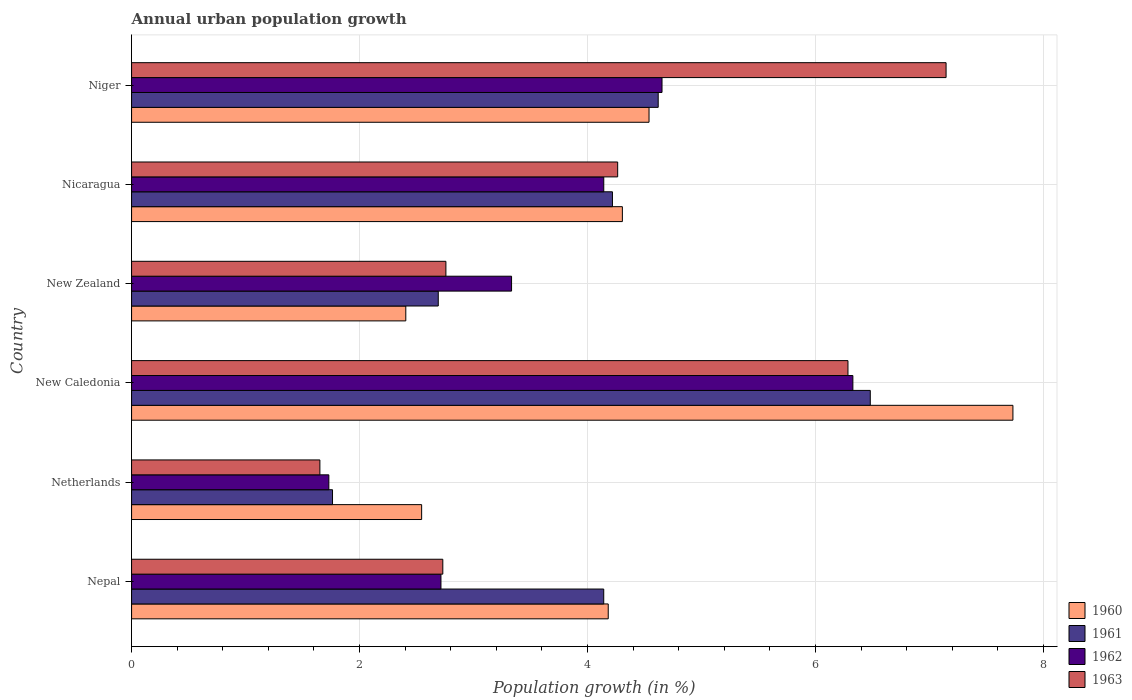Are the number of bars per tick equal to the number of legend labels?
Provide a succinct answer. Yes. Are the number of bars on each tick of the Y-axis equal?
Your answer should be compact. Yes. How many bars are there on the 3rd tick from the top?
Your answer should be compact. 4. What is the label of the 2nd group of bars from the top?
Your response must be concise. Nicaragua. What is the percentage of urban population growth in 1962 in Netherlands?
Ensure brevity in your answer.  1.73. Across all countries, what is the maximum percentage of urban population growth in 1961?
Your response must be concise. 6.48. Across all countries, what is the minimum percentage of urban population growth in 1961?
Offer a very short reply. 1.76. In which country was the percentage of urban population growth in 1963 maximum?
Ensure brevity in your answer.  Niger. In which country was the percentage of urban population growth in 1960 minimum?
Make the answer very short. New Zealand. What is the total percentage of urban population growth in 1963 in the graph?
Give a very brief answer. 24.83. What is the difference between the percentage of urban population growth in 1961 in Netherlands and that in Niger?
Offer a very short reply. -2.86. What is the difference between the percentage of urban population growth in 1962 in Nepal and the percentage of urban population growth in 1961 in New Caledonia?
Offer a very short reply. -3.77. What is the average percentage of urban population growth in 1961 per country?
Offer a terse response. 3.99. What is the difference between the percentage of urban population growth in 1962 and percentage of urban population growth in 1961 in Netherlands?
Provide a succinct answer. -0.03. In how many countries, is the percentage of urban population growth in 1962 greater than 3.6 %?
Provide a short and direct response. 3. What is the ratio of the percentage of urban population growth in 1961 in New Zealand to that in Nicaragua?
Offer a terse response. 0.64. Is the percentage of urban population growth in 1960 in New Caledonia less than that in Niger?
Keep it short and to the point. No. What is the difference between the highest and the second highest percentage of urban population growth in 1961?
Your answer should be compact. 1.86. What is the difference between the highest and the lowest percentage of urban population growth in 1963?
Keep it short and to the point. 5.49. Is it the case that in every country, the sum of the percentage of urban population growth in 1962 and percentage of urban population growth in 1960 is greater than the sum of percentage of urban population growth in 1961 and percentage of urban population growth in 1963?
Give a very brief answer. No. What does the 2nd bar from the top in Nicaragua represents?
Your answer should be very brief. 1962. How many bars are there?
Your response must be concise. 24. Are all the bars in the graph horizontal?
Give a very brief answer. Yes. How many countries are there in the graph?
Your answer should be compact. 6. Does the graph contain grids?
Ensure brevity in your answer.  Yes. How many legend labels are there?
Your answer should be very brief. 4. What is the title of the graph?
Your answer should be compact. Annual urban population growth. Does "1991" appear as one of the legend labels in the graph?
Ensure brevity in your answer.  No. What is the label or title of the X-axis?
Your response must be concise. Population growth (in %). What is the label or title of the Y-axis?
Provide a succinct answer. Country. What is the Population growth (in %) of 1960 in Nepal?
Offer a terse response. 4.18. What is the Population growth (in %) of 1961 in Nepal?
Your response must be concise. 4.14. What is the Population growth (in %) of 1962 in Nepal?
Your response must be concise. 2.71. What is the Population growth (in %) of 1963 in Nepal?
Your answer should be compact. 2.73. What is the Population growth (in %) in 1960 in Netherlands?
Offer a very short reply. 2.54. What is the Population growth (in %) of 1961 in Netherlands?
Keep it short and to the point. 1.76. What is the Population growth (in %) of 1962 in Netherlands?
Provide a succinct answer. 1.73. What is the Population growth (in %) in 1963 in Netherlands?
Your answer should be very brief. 1.65. What is the Population growth (in %) in 1960 in New Caledonia?
Make the answer very short. 7.73. What is the Population growth (in %) of 1961 in New Caledonia?
Ensure brevity in your answer.  6.48. What is the Population growth (in %) in 1962 in New Caledonia?
Provide a succinct answer. 6.33. What is the Population growth (in %) of 1963 in New Caledonia?
Keep it short and to the point. 6.28. What is the Population growth (in %) of 1960 in New Zealand?
Make the answer very short. 2.41. What is the Population growth (in %) of 1961 in New Zealand?
Make the answer very short. 2.69. What is the Population growth (in %) in 1962 in New Zealand?
Provide a short and direct response. 3.33. What is the Population growth (in %) of 1963 in New Zealand?
Your response must be concise. 2.76. What is the Population growth (in %) in 1960 in Nicaragua?
Keep it short and to the point. 4.31. What is the Population growth (in %) of 1961 in Nicaragua?
Your answer should be very brief. 4.22. What is the Population growth (in %) of 1962 in Nicaragua?
Provide a short and direct response. 4.14. What is the Population growth (in %) in 1963 in Nicaragua?
Your response must be concise. 4.26. What is the Population growth (in %) in 1960 in Niger?
Provide a succinct answer. 4.54. What is the Population growth (in %) in 1961 in Niger?
Offer a very short reply. 4.62. What is the Population growth (in %) in 1962 in Niger?
Make the answer very short. 4.65. What is the Population growth (in %) in 1963 in Niger?
Your response must be concise. 7.15. Across all countries, what is the maximum Population growth (in %) of 1960?
Offer a terse response. 7.73. Across all countries, what is the maximum Population growth (in %) in 1961?
Keep it short and to the point. 6.48. Across all countries, what is the maximum Population growth (in %) of 1962?
Ensure brevity in your answer.  6.33. Across all countries, what is the maximum Population growth (in %) of 1963?
Ensure brevity in your answer.  7.15. Across all countries, what is the minimum Population growth (in %) in 1960?
Offer a very short reply. 2.41. Across all countries, what is the minimum Population growth (in %) of 1961?
Your answer should be very brief. 1.76. Across all countries, what is the minimum Population growth (in %) in 1962?
Provide a succinct answer. 1.73. Across all countries, what is the minimum Population growth (in %) in 1963?
Keep it short and to the point. 1.65. What is the total Population growth (in %) of 1960 in the graph?
Offer a terse response. 25.71. What is the total Population growth (in %) of 1961 in the graph?
Provide a short and direct response. 23.91. What is the total Population growth (in %) of 1962 in the graph?
Your response must be concise. 22.9. What is the total Population growth (in %) of 1963 in the graph?
Your answer should be compact. 24.83. What is the difference between the Population growth (in %) of 1960 in Nepal and that in Netherlands?
Offer a terse response. 1.64. What is the difference between the Population growth (in %) of 1961 in Nepal and that in Netherlands?
Provide a succinct answer. 2.38. What is the difference between the Population growth (in %) of 1962 in Nepal and that in Netherlands?
Give a very brief answer. 0.98. What is the difference between the Population growth (in %) of 1963 in Nepal and that in Netherlands?
Make the answer very short. 1.08. What is the difference between the Population growth (in %) in 1960 in Nepal and that in New Caledonia?
Ensure brevity in your answer.  -3.55. What is the difference between the Population growth (in %) of 1961 in Nepal and that in New Caledonia?
Your response must be concise. -2.34. What is the difference between the Population growth (in %) of 1962 in Nepal and that in New Caledonia?
Give a very brief answer. -3.61. What is the difference between the Population growth (in %) in 1963 in Nepal and that in New Caledonia?
Provide a short and direct response. -3.55. What is the difference between the Population growth (in %) in 1960 in Nepal and that in New Zealand?
Keep it short and to the point. 1.78. What is the difference between the Population growth (in %) of 1961 in Nepal and that in New Zealand?
Offer a terse response. 1.45. What is the difference between the Population growth (in %) of 1962 in Nepal and that in New Zealand?
Make the answer very short. -0.62. What is the difference between the Population growth (in %) of 1963 in Nepal and that in New Zealand?
Your response must be concise. -0.03. What is the difference between the Population growth (in %) of 1960 in Nepal and that in Nicaragua?
Your response must be concise. -0.12. What is the difference between the Population growth (in %) in 1961 in Nepal and that in Nicaragua?
Offer a very short reply. -0.08. What is the difference between the Population growth (in %) of 1962 in Nepal and that in Nicaragua?
Your answer should be very brief. -1.43. What is the difference between the Population growth (in %) in 1963 in Nepal and that in Nicaragua?
Provide a short and direct response. -1.53. What is the difference between the Population growth (in %) in 1960 in Nepal and that in Niger?
Your response must be concise. -0.36. What is the difference between the Population growth (in %) of 1961 in Nepal and that in Niger?
Offer a terse response. -0.48. What is the difference between the Population growth (in %) in 1962 in Nepal and that in Niger?
Your answer should be very brief. -1.94. What is the difference between the Population growth (in %) of 1963 in Nepal and that in Niger?
Keep it short and to the point. -4.42. What is the difference between the Population growth (in %) in 1960 in Netherlands and that in New Caledonia?
Your answer should be compact. -5.19. What is the difference between the Population growth (in %) of 1961 in Netherlands and that in New Caledonia?
Provide a succinct answer. -4.72. What is the difference between the Population growth (in %) in 1962 in Netherlands and that in New Caledonia?
Provide a short and direct response. -4.6. What is the difference between the Population growth (in %) in 1963 in Netherlands and that in New Caledonia?
Keep it short and to the point. -4.63. What is the difference between the Population growth (in %) in 1960 in Netherlands and that in New Zealand?
Make the answer very short. 0.14. What is the difference between the Population growth (in %) of 1961 in Netherlands and that in New Zealand?
Give a very brief answer. -0.93. What is the difference between the Population growth (in %) in 1962 in Netherlands and that in New Zealand?
Your answer should be compact. -1.6. What is the difference between the Population growth (in %) of 1963 in Netherlands and that in New Zealand?
Your answer should be compact. -1.11. What is the difference between the Population growth (in %) of 1960 in Netherlands and that in Nicaragua?
Keep it short and to the point. -1.76. What is the difference between the Population growth (in %) in 1961 in Netherlands and that in Nicaragua?
Offer a very short reply. -2.46. What is the difference between the Population growth (in %) of 1962 in Netherlands and that in Nicaragua?
Give a very brief answer. -2.41. What is the difference between the Population growth (in %) in 1963 in Netherlands and that in Nicaragua?
Your answer should be compact. -2.61. What is the difference between the Population growth (in %) of 1960 in Netherlands and that in Niger?
Make the answer very short. -1.99. What is the difference between the Population growth (in %) in 1961 in Netherlands and that in Niger?
Keep it short and to the point. -2.86. What is the difference between the Population growth (in %) of 1962 in Netherlands and that in Niger?
Offer a terse response. -2.92. What is the difference between the Population growth (in %) in 1963 in Netherlands and that in Niger?
Provide a short and direct response. -5.49. What is the difference between the Population growth (in %) in 1960 in New Caledonia and that in New Zealand?
Your response must be concise. 5.33. What is the difference between the Population growth (in %) of 1961 in New Caledonia and that in New Zealand?
Make the answer very short. 3.79. What is the difference between the Population growth (in %) in 1962 in New Caledonia and that in New Zealand?
Your response must be concise. 2.99. What is the difference between the Population growth (in %) of 1963 in New Caledonia and that in New Zealand?
Provide a succinct answer. 3.53. What is the difference between the Population growth (in %) of 1960 in New Caledonia and that in Nicaragua?
Your answer should be compact. 3.43. What is the difference between the Population growth (in %) of 1961 in New Caledonia and that in Nicaragua?
Provide a short and direct response. 2.26. What is the difference between the Population growth (in %) in 1962 in New Caledonia and that in Nicaragua?
Make the answer very short. 2.19. What is the difference between the Population growth (in %) of 1963 in New Caledonia and that in Nicaragua?
Your answer should be very brief. 2.02. What is the difference between the Population growth (in %) of 1960 in New Caledonia and that in Niger?
Offer a very short reply. 3.19. What is the difference between the Population growth (in %) of 1961 in New Caledonia and that in Niger?
Give a very brief answer. 1.86. What is the difference between the Population growth (in %) of 1962 in New Caledonia and that in Niger?
Keep it short and to the point. 1.67. What is the difference between the Population growth (in %) in 1963 in New Caledonia and that in Niger?
Make the answer very short. -0.86. What is the difference between the Population growth (in %) of 1960 in New Zealand and that in Nicaragua?
Your response must be concise. -1.9. What is the difference between the Population growth (in %) in 1961 in New Zealand and that in Nicaragua?
Your response must be concise. -1.53. What is the difference between the Population growth (in %) of 1962 in New Zealand and that in Nicaragua?
Provide a succinct answer. -0.81. What is the difference between the Population growth (in %) in 1963 in New Zealand and that in Nicaragua?
Your answer should be very brief. -1.51. What is the difference between the Population growth (in %) in 1960 in New Zealand and that in Niger?
Offer a terse response. -2.13. What is the difference between the Population growth (in %) of 1961 in New Zealand and that in Niger?
Provide a short and direct response. -1.93. What is the difference between the Population growth (in %) in 1962 in New Zealand and that in Niger?
Ensure brevity in your answer.  -1.32. What is the difference between the Population growth (in %) in 1963 in New Zealand and that in Niger?
Offer a terse response. -4.39. What is the difference between the Population growth (in %) of 1960 in Nicaragua and that in Niger?
Keep it short and to the point. -0.23. What is the difference between the Population growth (in %) of 1961 in Nicaragua and that in Niger?
Offer a very short reply. -0.4. What is the difference between the Population growth (in %) in 1962 in Nicaragua and that in Niger?
Your response must be concise. -0.51. What is the difference between the Population growth (in %) of 1963 in Nicaragua and that in Niger?
Offer a very short reply. -2.88. What is the difference between the Population growth (in %) of 1960 in Nepal and the Population growth (in %) of 1961 in Netherlands?
Ensure brevity in your answer.  2.42. What is the difference between the Population growth (in %) of 1960 in Nepal and the Population growth (in %) of 1962 in Netherlands?
Your answer should be very brief. 2.45. What is the difference between the Population growth (in %) in 1960 in Nepal and the Population growth (in %) in 1963 in Netherlands?
Your answer should be compact. 2.53. What is the difference between the Population growth (in %) in 1961 in Nepal and the Population growth (in %) in 1962 in Netherlands?
Keep it short and to the point. 2.41. What is the difference between the Population growth (in %) in 1961 in Nepal and the Population growth (in %) in 1963 in Netherlands?
Your answer should be very brief. 2.49. What is the difference between the Population growth (in %) in 1962 in Nepal and the Population growth (in %) in 1963 in Netherlands?
Make the answer very short. 1.06. What is the difference between the Population growth (in %) of 1960 in Nepal and the Population growth (in %) of 1961 in New Caledonia?
Give a very brief answer. -2.3. What is the difference between the Population growth (in %) of 1960 in Nepal and the Population growth (in %) of 1962 in New Caledonia?
Make the answer very short. -2.15. What is the difference between the Population growth (in %) of 1960 in Nepal and the Population growth (in %) of 1963 in New Caledonia?
Provide a short and direct response. -2.1. What is the difference between the Population growth (in %) in 1961 in Nepal and the Population growth (in %) in 1962 in New Caledonia?
Ensure brevity in your answer.  -2.19. What is the difference between the Population growth (in %) of 1961 in Nepal and the Population growth (in %) of 1963 in New Caledonia?
Give a very brief answer. -2.14. What is the difference between the Population growth (in %) of 1962 in Nepal and the Population growth (in %) of 1963 in New Caledonia?
Provide a short and direct response. -3.57. What is the difference between the Population growth (in %) in 1960 in Nepal and the Population growth (in %) in 1961 in New Zealand?
Make the answer very short. 1.49. What is the difference between the Population growth (in %) of 1960 in Nepal and the Population growth (in %) of 1962 in New Zealand?
Offer a very short reply. 0.85. What is the difference between the Population growth (in %) in 1960 in Nepal and the Population growth (in %) in 1963 in New Zealand?
Your answer should be compact. 1.42. What is the difference between the Population growth (in %) in 1961 in Nepal and the Population growth (in %) in 1962 in New Zealand?
Your response must be concise. 0.81. What is the difference between the Population growth (in %) in 1961 in Nepal and the Population growth (in %) in 1963 in New Zealand?
Provide a succinct answer. 1.38. What is the difference between the Population growth (in %) of 1962 in Nepal and the Population growth (in %) of 1963 in New Zealand?
Ensure brevity in your answer.  -0.04. What is the difference between the Population growth (in %) in 1960 in Nepal and the Population growth (in %) in 1961 in Nicaragua?
Offer a terse response. -0.04. What is the difference between the Population growth (in %) in 1960 in Nepal and the Population growth (in %) in 1962 in Nicaragua?
Your answer should be very brief. 0.04. What is the difference between the Population growth (in %) in 1960 in Nepal and the Population growth (in %) in 1963 in Nicaragua?
Your response must be concise. -0.08. What is the difference between the Population growth (in %) of 1961 in Nepal and the Population growth (in %) of 1962 in Nicaragua?
Offer a terse response. -0. What is the difference between the Population growth (in %) of 1961 in Nepal and the Population growth (in %) of 1963 in Nicaragua?
Your answer should be very brief. -0.12. What is the difference between the Population growth (in %) in 1962 in Nepal and the Population growth (in %) in 1963 in Nicaragua?
Make the answer very short. -1.55. What is the difference between the Population growth (in %) of 1960 in Nepal and the Population growth (in %) of 1961 in Niger?
Make the answer very short. -0.44. What is the difference between the Population growth (in %) of 1960 in Nepal and the Population growth (in %) of 1962 in Niger?
Ensure brevity in your answer.  -0.47. What is the difference between the Population growth (in %) of 1960 in Nepal and the Population growth (in %) of 1963 in Niger?
Offer a very short reply. -2.96. What is the difference between the Population growth (in %) of 1961 in Nepal and the Population growth (in %) of 1962 in Niger?
Your answer should be compact. -0.51. What is the difference between the Population growth (in %) of 1961 in Nepal and the Population growth (in %) of 1963 in Niger?
Ensure brevity in your answer.  -3. What is the difference between the Population growth (in %) in 1962 in Nepal and the Population growth (in %) in 1963 in Niger?
Your answer should be very brief. -4.43. What is the difference between the Population growth (in %) in 1960 in Netherlands and the Population growth (in %) in 1961 in New Caledonia?
Offer a terse response. -3.94. What is the difference between the Population growth (in %) of 1960 in Netherlands and the Population growth (in %) of 1962 in New Caledonia?
Provide a succinct answer. -3.78. What is the difference between the Population growth (in %) of 1960 in Netherlands and the Population growth (in %) of 1963 in New Caledonia?
Provide a short and direct response. -3.74. What is the difference between the Population growth (in %) in 1961 in Netherlands and the Population growth (in %) in 1962 in New Caledonia?
Your response must be concise. -4.56. What is the difference between the Population growth (in %) in 1961 in Netherlands and the Population growth (in %) in 1963 in New Caledonia?
Keep it short and to the point. -4.52. What is the difference between the Population growth (in %) of 1962 in Netherlands and the Population growth (in %) of 1963 in New Caledonia?
Your response must be concise. -4.55. What is the difference between the Population growth (in %) in 1960 in Netherlands and the Population growth (in %) in 1961 in New Zealand?
Your response must be concise. -0.15. What is the difference between the Population growth (in %) in 1960 in Netherlands and the Population growth (in %) in 1962 in New Zealand?
Offer a terse response. -0.79. What is the difference between the Population growth (in %) in 1960 in Netherlands and the Population growth (in %) in 1963 in New Zealand?
Keep it short and to the point. -0.21. What is the difference between the Population growth (in %) in 1961 in Netherlands and the Population growth (in %) in 1962 in New Zealand?
Keep it short and to the point. -1.57. What is the difference between the Population growth (in %) of 1961 in Netherlands and the Population growth (in %) of 1963 in New Zealand?
Your response must be concise. -0.99. What is the difference between the Population growth (in %) of 1962 in Netherlands and the Population growth (in %) of 1963 in New Zealand?
Your response must be concise. -1.03. What is the difference between the Population growth (in %) in 1960 in Netherlands and the Population growth (in %) in 1961 in Nicaragua?
Give a very brief answer. -1.67. What is the difference between the Population growth (in %) of 1960 in Netherlands and the Population growth (in %) of 1962 in Nicaragua?
Your answer should be very brief. -1.6. What is the difference between the Population growth (in %) in 1960 in Netherlands and the Population growth (in %) in 1963 in Nicaragua?
Provide a succinct answer. -1.72. What is the difference between the Population growth (in %) of 1961 in Netherlands and the Population growth (in %) of 1962 in Nicaragua?
Make the answer very short. -2.38. What is the difference between the Population growth (in %) in 1961 in Netherlands and the Population growth (in %) in 1963 in Nicaragua?
Offer a terse response. -2.5. What is the difference between the Population growth (in %) in 1962 in Netherlands and the Population growth (in %) in 1963 in Nicaragua?
Your response must be concise. -2.53. What is the difference between the Population growth (in %) in 1960 in Netherlands and the Population growth (in %) in 1961 in Niger?
Offer a very short reply. -2.08. What is the difference between the Population growth (in %) in 1960 in Netherlands and the Population growth (in %) in 1962 in Niger?
Provide a short and direct response. -2.11. What is the difference between the Population growth (in %) in 1960 in Netherlands and the Population growth (in %) in 1963 in Niger?
Offer a very short reply. -4.6. What is the difference between the Population growth (in %) of 1961 in Netherlands and the Population growth (in %) of 1962 in Niger?
Provide a short and direct response. -2.89. What is the difference between the Population growth (in %) in 1961 in Netherlands and the Population growth (in %) in 1963 in Niger?
Provide a short and direct response. -5.38. What is the difference between the Population growth (in %) in 1962 in Netherlands and the Population growth (in %) in 1963 in Niger?
Ensure brevity in your answer.  -5.41. What is the difference between the Population growth (in %) of 1960 in New Caledonia and the Population growth (in %) of 1961 in New Zealand?
Provide a short and direct response. 5.04. What is the difference between the Population growth (in %) of 1960 in New Caledonia and the Population growth (in %) of 1962 in New Zealand?
Your answer should be very brief. 4.4. What is the difference between the Population growth (in %) in 1960 in New Caledonia and the Population growth (in %) in 1963 in New Zealand?
Your answer should be compact. 4.97. What is the difference between the Population growth (in %) in 1961 in New Caledonia and the Population growth (in %) in 1962 in New Zealand?
Provide a succinct answer. 3.15. What is the difference between the Population growth (in %) in 1961 in New Caledonia and the Population growth (in %) in 1963 in New Zealand?
Your response must be concise. 3.72. What is the difference between the Population growth (in %) in 1962 in New Caledonia and the Population growth (in %) in 1963 in New Zealand?
Keep it short and to the point. 3.57. What is the difference between the Population growth (in %) of 1960 in New Caledonia and the Population growth (in %) of 1961 in Nicaragua?
Your response must be concise. 3.51. What is the difference between the Population growth (in %) in 1960 in New Caledonia and the Population growth (in %) in 1962 in Nicaragua?
Ensure brevity in your answer.  3.59. What is the difference between the Population growth (in %) of 1960 in New Caledonia and the Population growth (in %) of 1963 in Nicaragua?
Your answer should be compact. 3.47. What is the difference between the Population growth (in %) in 1961 in New Caledonia and the Population growth (in %) in 1962 in Nicaragua?
Make the answer very short. 2.34. What is the difference between the Population growth (in %) in 1961 in New Caledonia and the Population growth (in %) in 1963 in Nicaragua?
Offer a very short reply. 2.22. What is the difference between the Population growth (in %) of 1962 in New Caledonia and the Population growth (in %) of 1963 in Nicaragua?
Your response must be concise. 2.06. What is the difference between the Population growth (in %) in 1960 in New Caledonia and the Population growth (in %) in 1961 in Niger?
Your answer should be very brief. 3.11. What is the difference between the Population growth (in %) in 1960 in New Caledonia and the Population growth (in %) in 1962 in Niger?
Keep it short and to the point. 3.08. What is the difference between the Population growth (in %) of 1960 in New Caledonia and the Population growth (in %) of 1963 in Niger?
Provide a succinct answer. 0.59. What is the difference between the Population growth (in %) of 1961 in New Caledonia and the Population growth (in %) of 1962 in Niger?
Your response must be concise. 1.83. What is the difference between the Population growth (in %) in 1961 in New Caledonia and the Population growth (in %) in 1963 in Niger?
Provide a short and direct response. -0.67. What is the difference between the Population growth (in %) of 1962 in New Caledonia and the Population growth (in %) of 1963 in Niger?
Give a very brief answer. -0.82. What is the difference between the Population growth (in %) of 1960 in New Zealand and the Population growth (in %) of 1961 in Nicaragua?
Keep it short and to the point. -1.81. What is the difference between the Population growth (in %) in 1960 in New Zealand and the Population growth (in %) in 1962 in Nicaragua?
Your response must be concise. -1.74. What is the difference between the Population growth (in %) in 1960 in New Zealand and the Population growth (in %) in 1963 in Nicaragua?
Your answer should be compact. -1.86. What is the difference between the Population growth (in %) in 1961 in New Zealand and the Population growth (in %) in 1962 in Nicaragua?
Give a very brief answer. -1.45. What is the difference between the Population growth (in %) in 1961 in New Zealand and the Population growth (in %) in 1963 in Nicaragua?
Your answer should be compact. -1.57. What is the difference between the Population growth (in %) in 1962 in New Zealand and the Population growth (in %) in 1963 in Nicaragua?
Ensure brevity in your answer.  -0.93. What is the difference between the Population growth (in %) of 1960 in New Zealand and the Population growth (in %) of 1961 in Niger?
Provide a short and direct response. -2.21. What is the difference between the Population growth (in %) of 1960 in New Zealand and the Population growth (in %) of 1962 in Niger?
Your answer should be compact. -2.25. What is the difference between the Population growth (in %) in 1960 in New Zealand and the Population growth (in %) in 1963 in Niger?
Provide a succinct answer. -4.74. What is the difference between the Population growth (in %) in 1961 in New Zealand and the Population growth (in %) in 1962 in Niger?
Make the answer very short. -1.96. What is the difference between the Population growth (in %) of 1961 in New Zealand and the Population growth (in %) of 1963 in Niger?
Ensure brevity in your answer.  -4.46. What is the difference between the Population growth (in %) of 1962 in New Zealand and the Population growth (in %) of 1963 in Niger?
Your answer should be very brief. -3.81. What is the difference between the Population growth (in %) in 1960 in Nicaragua and the Population growth (in %) in 1961 in Niger?
Provide a short and direct response. -0.31. What is the difference between the Population growth (in %) of 1960 in Nicaragua and the Population growth (in %) of 1962 in Niger?
Your answer should be compact. -0.35. What is the difference between the Population growth (in %) of 1960 in Nicaragua and the Population growth (in %) of 1963 in Niger?
Keep it short and to the point. -2.84. What is the difference between the Population growth (in %) of 1961 in Nicaragua and the Population growth (in %) of 1962 in Niger?
Provide a succinct answer. -0.43. What is the difference between the Population growth (in %) of 1961 in Nicaragua and the Population growth (in %) of 1963 in Niger?
Provide a succinct answer. -2.93. What is the difference between the Population growth (in %) in 1962 in Nicaragua and the Population growth (in %) in 1963 in Niger?
Your response must be concise. -3. What is the average Population growth (in %) of 1960 per country?
Keep it short and to the point. 4.28. What is the average Population growth (in %) of 1961 per country?
Offer a very short reply. 3.99. What is the average Population growth (in %) of 1962 per country?
Offer a terse response. 3.82. What is the average Population growth (in %) of 1963 per country?
Your answer should be compact. 4.14. What is the difference between the Population growth (in %) of 1960 and Population growth (in %) of 1961 in Nepal?
Your response must be concise. 0.04. What is the difference between the Population growth (in %) of 1960 and Population growth (in %) of 1962 in Nepal?
Your response must be concise. 1.47. What is the difference between the Population growth (in %) in 1960 and Population growth (in %) in 1963 in Nepal?
Provide a succinct answer. 1.45. What is the difference between the Population growth (in %) of 1961 and Population growth (in %) of 1962 in Nepal?
Offer a terse response. 1.43. What is the difference between the Population growth (in %) in 1961 and Population growth (in %) in 1963 in Nepal?
Give a very brief answer. 1.41. What is the difference between the Population growth (in %) of 1962 and Population growth (in %) of 1963 in Nepal?
Your answer should be very brief. -0.02. What is the difference between the Population growth (in %) of 1960 and Population growth (in %) of 1961 in Netherlands?
Give a very brief answer. 0.78. What is the difference between the Population growth (in %) of 1960 and Population growth (in %) of 1962 in Netherlands?
Keep it short and to the point. 0.81. What is the difference between the Population growth (in %) of 1960 and Population growth (in %) of 1963 in Netherlands?
Your answer should be very brief. 0.89. What is the difference between the Population growth (in %) of 1961 and Population growth (in %) of 1962 in Netherlands?
Provide a short and direct response. 0.03. What is the difference between the Population growth (in %) in 1961 and Population growth (in %) in 1963 in Netherlands?
Your answer should be very brief. 0.11. What is the difference between the Population growth (in %) in 1962 and Population growth (in %) in 1963 in Netherlands?
Keep it short and to the point. 0.08. What is the difference between the Population growth (in %) of 1960 and Population growth (in %) of 1961 in New Caledonia?
Ensure brevity in your answer.  1.25. What is the difference between the Population growth (in %) of 1960 and Population growth (in %) of 1962 in New Caledonia?
Offer a very short reply. 1.4. What is the difference between the Population growth (in %) of 1960 and Population growth (in %) of 1963 in New Caledonia?
Your answer should be compact. 1.45. What is the difference between the Population growth (in %) in 1961 and Population growth (in %) in 1962 in New Caledonia?
Offer a terse response. 0.15. What is the difference between the Population growth (in %) of 1961 and Population growth (in %) of 1963 in New Caledonia?
Ensure brevity in your answer.  0.2. What is the difference between the Population growth (in %) in 1962 and Population growth (in %) in 1963 in New Caledonia?
Your answer should be very brief. 0.04. What is the difference between the Population growth (in %) in 1960 and Population growth (in %) in 1961 in New Zealand?
Your answer should be compact. -0.28. What is the difference between the Population growth (in %) in 1960 and Population growth (in %) in 1962 in New Zealand?
Offer a very short reply. -0.93. What is the difference between the Population growth (in %) of 1960 and Population growth (in %) of 1963 in New Zealand?
Make the answer very short. -0.35. What is the difference between the Population growth (in %) of 1961 and Population growth (in %) of 1962 in New Zealand?
Your answer should be compact. -0.64. What is the difference between the Population growth (in %) in 1961 and Population growth (in %) in 1963 in New Zealand?
Your response must be concise. -0.07. What is the difference between the Population growth (in %) in 1962 and Population growth (in %) in 1963 in New Zealand?
Provide a succinct answer. 0.58. What is the difference between the Population growth (in %) of 1960 and Population growth (in %) of 1961 in Nicaragua?
Give a very brief answer. 0.09. What is the difference between the Population growth (in %) in 1960 and Population growth (in %) in 1962 in Nicaragua?
Your answer should be compact. 0.16. What is the difference between the Population growth (in %) in 1960 and Population growth (in %) in 1963 in Nicaragua?
Provide a succinct answer. 0.04. What is the difference between the Population growth (in %) in 1961 and Population growth (in %) in 1962 in Nicaragua?
Your response must be concise. 0.08. What is the difference between the Population growth (in %) of 1961 and Population growth (in %) of 1963 in Nicaragua?
Make the answer very short. -0.05. What is the difference between the Population growth (in %) in 1962 and Population growth (in %) in 1963 in Nicaragua?
Make the answer very short. -0.12. What is the difference between the Population growth (in %) of 1960 and Population growth (in %) of 1961 in Niger?
Your answer should be compact. -0.08. What is the difference between the Population growth (in %) in 1960 and Population growth (in %) in 1962 in Niger?
Keep it short and to the point. -0.11. What is the difference between the Population growth (in %) in 1960 and Population growth (in %) in 1963 in Niger?
Offer a very short reply. -2.61. What is the difference between the Population growth (in %) of 1961 and Population growth (in %) of 1962 in Niger?
Your response must be concise. -0.03. What is the difference between the Population growth (in %) in 1961 and Population growth (in %) in 1963 in Niger?
Offer a terse response. -2.53. What is the difference between the Population growth (in %) in 1962 and Population growth (in %) in 1963 in Niger?
Keep it short and to the point. -2.49. What is the ratio of the Population growth (in %) in 1960 in Nepal to that in Netherlands?
Your answer should be very brief. 1.64. What is the ratio of the Population growth (in %) in 1961 in Nepal to that in Netherlands?
Your response must be concise. 2.35. What is the ratio of the Population growth (in %) in 1962 in Nepal to that in Netherlands?
Keep it short and to the point. 1.57. What is the ratio of the Population growth (in %) of 1963 in Nepal to that in Netherlands?
Offer a terse response. 1.65. What is the ratio of the Population growth (in %) of 1960 in Nepal to that in New Caledonia?
Provide a succinct answer. 0.54. What is the ratio of the Population growth (in %) in 1961 in Nepal to that in New Caledonia?
Ensure brevity in your answer.  0.64. What is the ratio of the Population growth (in %) in 1962 in Nepal to that in New Caledonia?
Give a very brief answer. 0.43. What is the ratio of the Population growth (in %) of 1963 in Nepal to that in New Caledonia?
Keep it short and to the point. 0.43. What is the ratio of the Population growth (in %) in 1960 in Nepal to that in New Zealand?
Provide a succinct answer. 1.74. What is the ratio of the Population growth (in %) of 1961 in Nepal to that in New Zealand?
Give a very brief answer. 1.54. What is the ratio of the Population growth (in %) in 1962 in Nepal to that in New Zealand?
Provide a short and direct response. 0.81. What is the ratio of the Population growth (in %) in 1963 in Nepal to that in New Zealand?
Provide a succinct answer. 0.99. What is the ratio of the Population growth (in %) in 1960 in Nepal to that in Nicaragua?
Your answer should be compact. 0.97. What is the ratio of the Population growth (in %) of 1961 in Nepal to that in Nicaragua?
Offer a very short reply. 0.98. What is the ratio of the Population growth (in %) of 1962 in Nepal to that in Nicaragua?
Ensure brevity in your answer.  0.66. What is the ratio of the Population growth (in %) in 1963 in Nepal to that in Nicaragua?
Provide a succinct answer. 0.64. What is the ratio of the Population growth (in %) of 1960 in Nepal to that in Niger?
Offer a terse response. 0.92. What is the ratio of the Population growth (in %) in 1961 in Nepal to that in Niger?
Offer a very short reply. 0.9. What is the ratio of the Population growth (in %) of 1962 in Nepal to that in Niger?
Offer a very short reply. 0.58. What is the ratio of the Population growth (in %) in 1963 in Nepal to that in Niger?
Ensure brevity in your answer.  0.38. What is the ratio of the Population growth (in %) in 1960 in Netherlands to that in New Caledonia?
Give a very brief answer. 0.33. What is the ratio of the Population growth (in %) in 1961 in Netherlands to that in New Caledonia?
Provide a succinct answer. 0.27. What is the ratio of the Population growth (in %) in 1962 in Netherlands to that in New Caledonia?
Make the answer very short. 0.27. What is the ratio of the Population growth (in %) of 1963 in Netherlands to that in New Caledonia?
Give a very brief answer. 0.26. What is the ratio of the Population growth (in %) in 1960 in Netherlands to that in New Zealand?
Make the answer very short. 1.06. What is the ratio of the Population growth (in %) of 1961 in Netherlands to that in New Zealand?
Provide a succinct answer. 0.66. What is the ratio of the Population growth (in %) in 1962 in Netherlands to that in New Zealand?
Your answer should be very brief. 0.52. What is the ratio of the Population growth (in %) in 1963 in Netherlands to that in New Zealand?
Your answer should be very brief. 0.6. What is the ratio of the Population growth (in %) in 1960 in Netherlands to that in Nicaragua?
Your answer should be very brief. 0.59. What is the ratio of the Population growth (in %) of 1961 in Netherlands to that in Nicaragua?
Provide a short and direct response. 0.42. What is the ratio of the Population growth (in %) of 1962 in Netherlands to that in Nicaragua?
Keep it short and to the point. 0.42. What is the ratio of the Population growth (in %) of 1963 in Netherlands to that in Nicaragua?
Make the answer very short. 0.39. What is the ratio of the Population growth (in %) in 1960 in Netherlands to that in Niger?
Your answer should be very brief. 0.56. What is the ratio of the Population growth (in %) in 1961 in Netherlands to that in Niger?
Make the answer very short. 0.38. What is the ratio of the Population growth (in %) of 1962 in Netherlands to that in Niger?
Provide a succinct answer. 0.37. What is the ratio of the Population growth (in %) of 1963 in Netherlands to that in Niger?
Give a very brief answer. 0.23. What is the ratio of the Population growth (in %) in 1960 in New Caledonia to that in New Zealand?
Your response must be concise. 3.21. What is the ratio of the Population growth (in %) in 1961 in New Caledonia to that in New Zealand?
Offer a very short reply. 2.41. What is the ratio of the Population growth (in %) of 1962 in New Caledonia to that in New Zealand?
Your answer should be very brief. 1.9. What is the ratio of the Population growth (in %) in 1963 in New Caledonia to that in New Zealand?
Your answer should be very brief. 2.28. What is the ratio of the Population growth (in %) of 1960 in New Caledonia to that in Nicaragua?
Ensure brevity in your answer.  1.8. What is the ratio of the Population growth (in %) in 1961 in New Caledonia to that in Nicaragua?
Offer a very short reply. 1.54. What is the ratio of the Population growth (in %) in 1962 in New Caledonia to that in Nicaragua?
Give a very brief answer. 1.53. What is the ratio of the Population growth (in %) in 1963 in New Caledonia to that in Nicaragua?
Provide a succinct answer. 1.47. What is the ratio of the Population growth (in %) of 1960 in New Caledonia to that in Niger?
Offer a terse response. 1.7. What is the ratio of the Population growth (in %) in 1961 in New Caledonia to that in Niger?
Provide a succinct answer. 1.4. What is the ratio of the Population growth (in %) in 1962 in New Caledonia to that in Niger?
Offer a very short reply. 1.36. What is the ratio of the Population growth (in %) in 1963 in New Caledonia to that in Niger?
Make the answer very short. 0.88. What is the ratio of the Population growth (in %) in 1960 in New Zealand to that in Nicaragua?
Offer a very short reply. 0.56. What is the ratio of the Population growth (in %) in 1961 in New Zealand to that in Nicaragua?
Your answer should be compact. 0.64. What is the ratio of the Population growth (in %) of 1962 in New Zealand to that in Nicaragua?
Provide a succinct answer. 0.8. What is the ratio of the Population growth (in %) of 1963 in New Zealand to that in Nicaragua?
Provide a short and direct response. 0.65. What is the ratio of the Population growth (in %) of 1960 in New Zealand to that in Niger?
Offer a terse response. 0.53. What is the ratio of the Population growth (in %) of 1961 in New Zealand to that in Niger?
Your answer should be compact. 0.58. What is the ratio of the Population growth (in %) of 1962 in New Zealand to that in Niger?
Offer a very short reply. 0.72. What is the ratio of the Population growth (in %) of 1963 in New Zealand to that in Niger?
Your response must be concise. 0.39. What is the ratio of the Population growth (in %) of 1960 in Nicaragua to that in Niger?
Offer a terse response. 0.95. What is the ratio of the Population growth (in %) in 1961 in Nicaragua to that in Niger?
Your response must be concise. 0.91. What is the ratio of the Population growth (in %) of 1962 in Nicaragua to that in Niger?
Give a very brief answer. 0.89. What is the ratio of the Population growth (in %) in 1963 in Nicaragua to that in Niger?
Offer a terse response. 0.6. What is the difference between the highest and the second highest Population growth (in %) of 1960?
Offer a terse response. 3.19. What is the difference between the highest and the second highest Population growth (in %) in 1961?
Your response must be concise. 1.86. What is the difference between the highest and the second highest Population growth (in %) in 1962?
Offer a terse response. 1.67. What is the difference between the highest and the second highest Population growth (in %) of 1963?
Offer a terse response. 0.86. What is the difference between the highest and the lowest Population growth (in %) in 1960?
Your response must be concise. 5.33. What is the difference between the highest and the lowest Population growth (in %) of 1961?
Ensure brevity in your answer.  4.72. What is the difference between the highest and the lowest Population growth (in %) of 1962?
Your answer should be compact. 4.6. What is the difference between the highest and the lowest Population growth (in %) of 1963?
Offer a terse response. 5.49. 